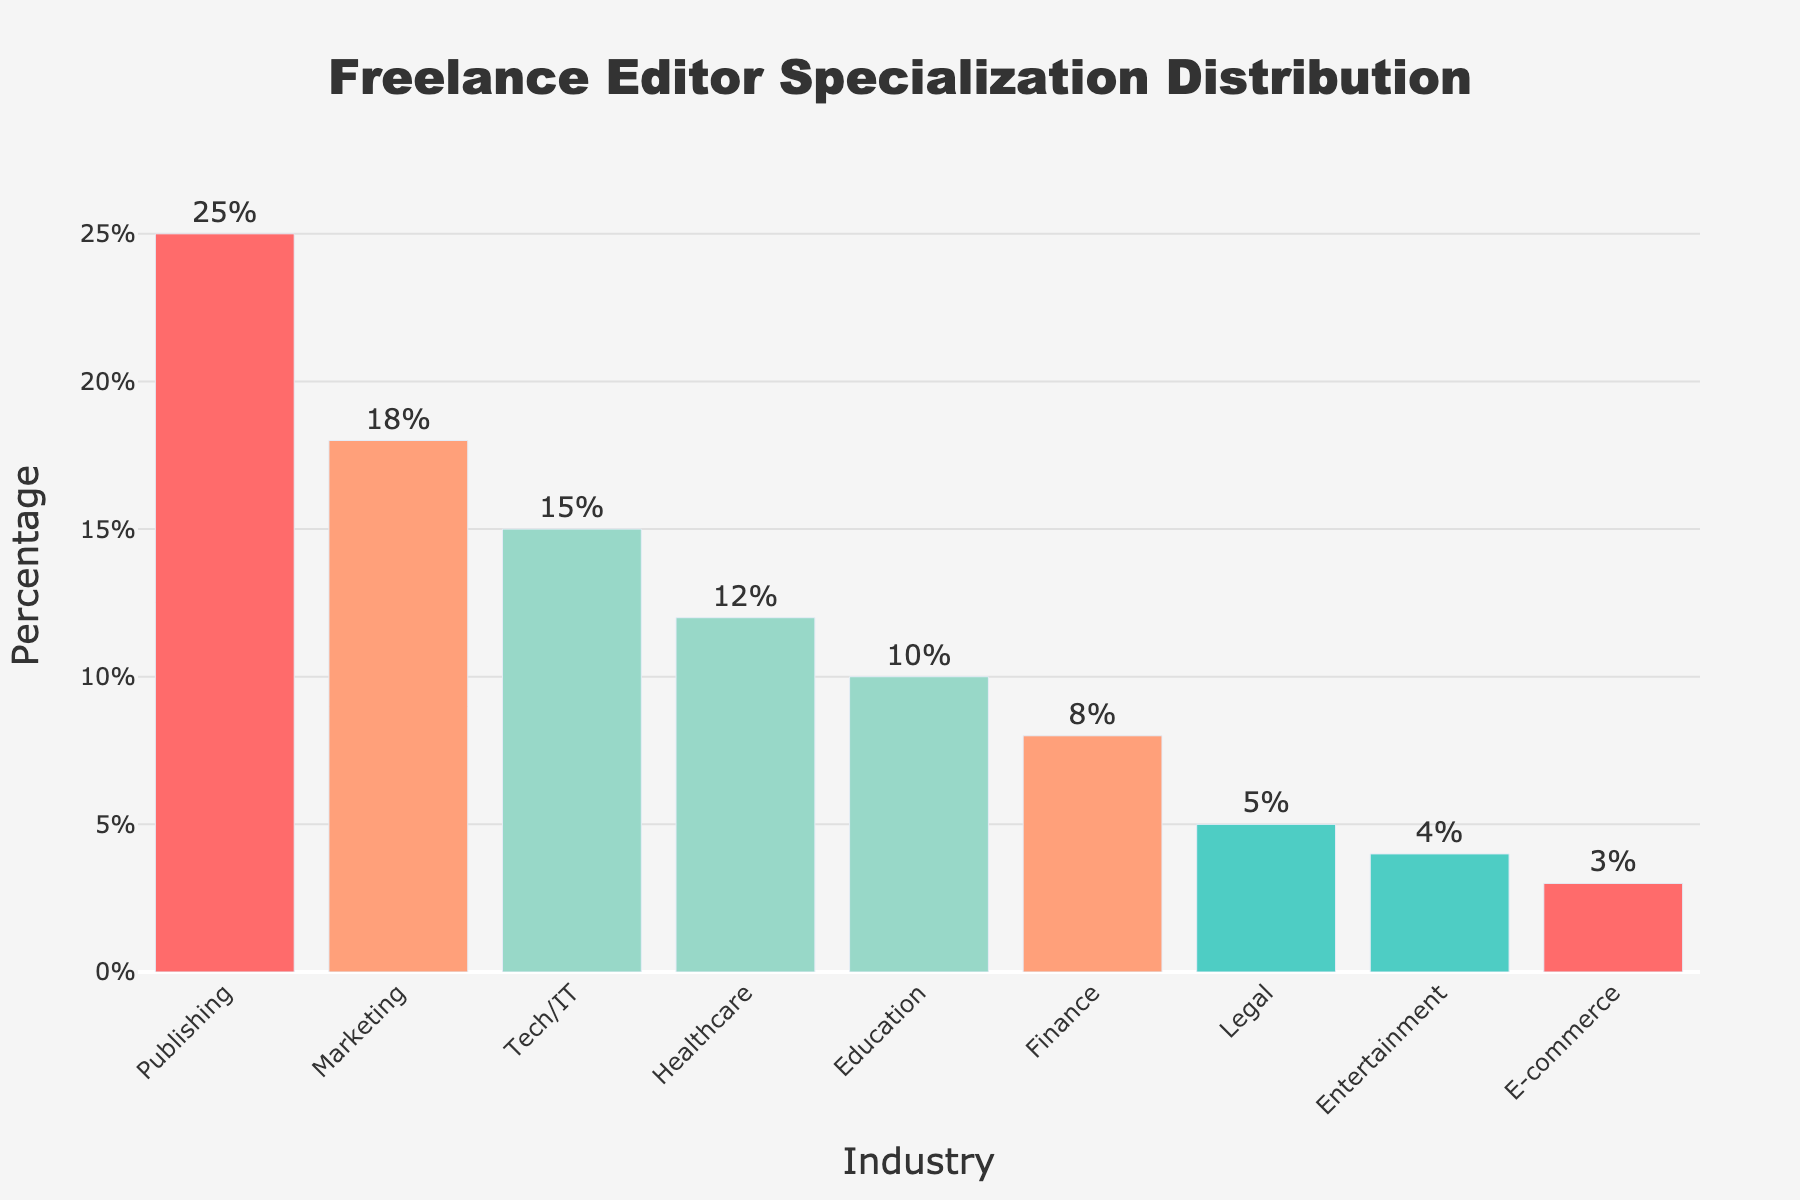What industry has the highest percentage of freelance editor specialization? The bar chart shows different industries and their respective percentages of freelance editor specialization. The bar with the highest value represents the industry with the highest percentage.
Answer: Publishing Which industry has a higher percentage, Marketing or Healthcare? Compare the heights of the bars for Marketing and Healthcare. The bar for Marketing is higher than the bar for Healthcare.
Answer: Marketing What is the total percentage of freelance editors specializing in Tech/IT and Finance combined? Sum the percentages of Tech/IT (15%) and Finance (8%). The calculation is 15% + 8%.
Answer: 23% How much larger is the percentage of freelance editors in Publishing compared to E-commerce? Subtract the percentage of E-commerce (3%) from Publishing (25%). The calculation is 25% - 3%.
Answer: 22% Which industries have a specialization percentage less than 10%? Identify the bars with percentages less than 10%. The bars for Finance, Legal, Entertainment, and E-commerce are all below 10%.
Answer: Finance, Legal, Entertainment, E-commerce Which industry has the shortest bar in the chart, and what is its percentage? The shortest bar represents the industry with the lowest percentage. Identify this bar and read its height. The shortest bar corresponds to E-commerce with 3%.
Answer: E-commerce, 3% Is the percentage of freelance editors specializing in Education closer to Healthcare or Finance? Compare the percentage of Education (10%) to those of Healthcare (12%) and Finance (8%). The difference between Education and Healthcare is 2% (12%-10%), and the difference between Education and Finance is 2% (10%-8%).
Answer: Both are equally close What is the average percentage of freelance editors across all industries? Sum the percentages of all industries and divide by the number of industries: (25% + 18% + 15% + 12% + 10% + 8% + 5% + 4% + 3%) / 9. The total sum is 100%, and the total number of industries is 9.
Answer: 11.1% How many industries have a specialization percentage higher than the average percentage? First, calculate the average percentage, which is 11.1%. Then, count the bars with percentages higher than 11.1%. They include Publishing, Marketing, Tech/IT, and Healthcare.
Answer: 4 